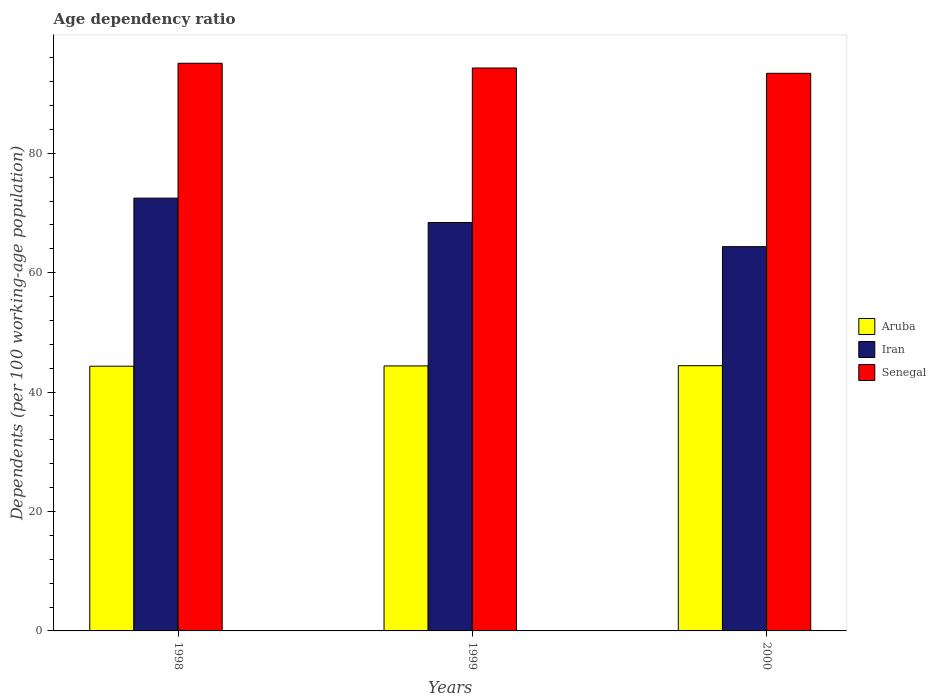How many different coloured bars are there?
Your answer should be compact. 3. How many groups of bars are there?
Your answer should be compact. 3. Are the number of bars on each tick of the X-axis equal?
Keep it short and to the point. Yes. How many bars are there on the 2nd tick from the right?
Your answer should be very brief. 3. What is the age dependency ratio in in Iran in 1999?
Offer a very short reply. 68.4. Across all years, what is the maximum age dependency ratio in in Senegal?
Offer a terse response. 95.07. Across all years, what is the minimum age dependency ratio in in Senegal?
Offer a terse response. 93.39. In which year was the age dependency ratio in in Senegal minimum?
Give a very brief answer. 2000. What is the total age dependency ratio in in Senegal in the graph?
Keep it short and to the point. 282.74. What is the difference between the age dependency ratio in in Iran in 1998 and that in 2000?
Keep it short and to the point. 8.12. What is the difference between the age dependency ratio in in Aruba in 2000 and the age dependency ratio in in Senegal in 1999?
Make the answer very short. -49.85. What is the average age dependency ratio in in Aruba per year?
Keep it short and to the point. 44.38. In the year 2000, what is the difference between the age dependency ratio in in Aruba and age dependency ratio in in Iran?
Ensure brevity in your answer.  -19.94. In how many years, is the age dependency ratio in in Iran greater than 76 %?
Make the answer very short. 0. What is the ratio of the age dependency ratio in in Aruba in 1998 to that in 1999?
Provide a succinct answer. 1. What is the difference between the highest and the second highest age dependency ratio in in Iran?
Ensure brevity in your answer.  4.08. What is the difference between the highest and the lowest age dependency ratio in in Senegal?
Your response must be concise. 1.68. In how many years, is the age dependency ratio in in Senegal greater than the average age dependency ratio in in Senegal taken over all years?
Your answer should be very brief. 2. What does the 2nd bar from the left in 1998 represents?
Your answer should be very brief. Iran. What does the 3rd bar from the right in 1999 represents?
Make the answer very short. Aruba. Is it the case that in every year, the sum of the age dependency ratio in in Senegal and age dependency ratio in in Iran is greater than the age dependency ratio in in Aruba?
Make the answer very short. Yes. How many bars are there?
Give a very brief answer. 9. What is the difference between two consecutive major ticks on the Y-axis?
Ensure brevity in your answer.  20. Does the graph contain grids?
Make the answer very short. No. Where does the legend appear in the graph?
Your response must be concise. Center right. How are the legend labels stacked?
Your answer should be very brief. Vertical. What is the title of the graph?
Ensure brevity in your answer.  Age dependency ratio. Does "St. Lucia" appear as one of the legend labels in the graph?
Ensure brevity in your answer.  No. What is the label or title of the Y-axis?
Provide a succinct answer. Dependents (per 100 working-age population). What is the Dependents (per 100 working-age population) in Aruba in 1998?
Your answer should be very brief. 44.33. What is the Dependents (per 100 working-age population) in Iran in 1998?
Provide a short and direct response. 72.48. What is the Dependents (per 100 working-age population) of Senegal in 1998?
Give a very brief answer. 95.07. What is the Dependents (per 100 working-age population) in Aruba in 1999?
Your response must be concise. 44.38. What is the Dependents (per 100 working-age population) of Iran in 1999?
Provide a succinct answer. 68.4. What is the Dependents (per 100 working-age population) in Senegal in 1999?
Your answer should be compact. 94.28. What is the Dependents (per 100 working-age population) in Aruba in 2000?
Make the answer very short. 44.42. What is the Dependents (per 100 working-age population) of Iran in 2000?
Keep it short and to the point. 64.36. What is the Dependents (per 100 working-age population) in Senegal in 2000?
Ensure brevity in your answer.  93.39. Across all years, what is the maximum Dependents (per 100 working-age population) of Aruba?
Offer a very short reply. 44.42. Across all years, what is the maximum Dependents (per 100 working-age population) of Iran?
Your response must be concise. 72.48. Across all years, what is the maximum Dependents (per 100 working-age population) of Senegal?
Make the answer very short. 95.07. Across all years, what is the minimum Dependents (per 100 working-age population) in Aruba?
Your answer should be compact. 44.33. Across all years, what is the minimum Dependents (per 100 working-age population) in Iran?
Provide a short and direct response. 64.36. Across all years, what is the minimum Dependents (per 100 working-age population) of Senegal?
Your answer should be very brief. 93.39. What is the total Dependents (per 100 working-age population) of Aruba in the graph?
Offer a terse response. 133.13. What is the total Dependents (per 100 working-age population) in Iran in the graph?
Provide a short and direct response. 205.24. What is the total Dependents (per 100 working-age population) of Senegal in the graph?
Keep it short and to the point. 282.74. What is the difference between the Dependents (per 100 working-age population) in Aruba in 1998 and that in 1999?
Keep it short and to the point. -0.04. What is the difference between the Dependents (per 100 working-age population) of Iran in 1998 and that in 1999?
Your answer should be very brief. 4.08. What is the difference between the Dependents (per 100 working-age population) of Senegal in 1998 and that in 1999?
Give a very brief answer. 0.8. What is the difference between the Dependents (per 100 working-age population) of Aruba in 1998 and that in 2000?
Your answer should be compact. -0.09. What is the difference between the Dependents (per 100 working-age population) of Iran in 1998 and that in 2000?
Keep it short and to the point. 8.12. What is the difference between the Dependents (per 100 working-age population) in Senegal in 1998 and that in 2000?
Your answer should be very brief. 1.68. What is the difference between the Dependents (per 100 working-age population) in Aruba in 1999 and that in 2000?
Keep it short and to the point. -0.04. What is the difference between the Dependents (per 100 working-age population) in Iran in 1999 and that in 2000?
Your answer should be compact. 4.04. What is the difference between the Dependents (per 100 working-age population) of Senegal in 1999 and that in 2000?
Provide a short and direct response. 0.89. What is the difference between the Dependents (per 100 working-age population) in Aruba in 1998 and the Dependents (per 100 working-age population) in Iran in 1999?
Offer a terse response. -24.07. What is the difference between the Dependents (per 100 working-age population) of Aruba in 1998 and the Dependents (per 100 working-age population) of Senegal in 1999?
Keep it short and to the point. -49.94. What is the difference between the Dependents (per 100 working-age population) of Iran in 1998 and the Dependents (per 100 working-age population) of Senegal in 1999?
Keep it short and to the point. -21.79. What is the difference between the Dependents (per 100 working-age population) in Aruba in 1998 and the Dependents (per 100 working-age population) in Iran in 2000?
Offer a very short reply. -20.02. What is the difference between the Dependents (per 100 working-age population) of Aruba in 1998 and the Dependents (per 100 working-age population) of Senegal in 2000?
Offer a terse response. -49.05. What is the difference between the Dependents (per 100 working-age population) in Iran in 1998 and the Dependents (per 100 working-age population) in Senegal in 2000?
Provide a short and direct response. -20.91. What is the difference between the Dependents (per 100 working-age population) in Aruba in 1999 and the Dependents (per 100 working-age population) in Iran in 2000?
Ensure brevity in your answer.  -19.98. What is the difference between the Dependents (per 100 working-age population) of Aruba in 1999 and the Dependents (per 100 working-age population) of Senegal in 2000?
Offer a very short reply. -49.01. What is the difference between the Dependents (per 100 working-age population) in Iran in 1999 and the Dependents (per 100 working-age population) in Senegal in 2000?
Your answer should be very brief. -24.99. What is the average Dependents (per 100 working-age population) in Aruba per year?
Your answer should be very brief. 44.38. What is the average Dependents (per 100 working-age population) of Iran per year?
Make the answer very short. 68.41. What is the average Dependents (per 100 working-age population) of Senegal per year?
Offer a very short reply. 94.25. In the year 1998, what is the difference between the Dependents (per 100 working-age population) in Aruba and Dependents (per 100 working-age population) in Iran?
Provide a succinct answer. -28.15. In the year 1998, what is the difference between the Dependents (per 100 working-age population) of Aruba and Dependents (per 100 working-age population) of Senegal?
Keep it short and to the point. -50.74. In the year 1998, what is the difference between the Dependents (per 100 working-age population) of Iran and Dependents (per 100 working-age population) of Senegal?
Make the answer very short. -22.59. In the year 1999, what is the difference between the Dependents (per 100 working-age population) of Aruba and Dependents (per 100 working-age population) of Iran?
Give a very brief answer. -24.02. In the year 1999, what is the difference between the Dependents (per 100 working-age population) in Aruba and Dependents (per 100 working-age population) in Senegal?
Keep it short and to the point. -49.9. In the year 1999, what is the difference between the Dependents (per 100 working-age population) of Iran and Dependents (per 100 working-age population) of Senegal?
Provide a short and direct response. -25.87. In the year 2000, what is the difference between the Dependents (per 100 working-age population) of Aruba and Dependents (per 100 working-age population) of Iran?
Make the answer very short. -19.94. In the year 2000, what is the difference between the Dependents (per 100 working-age population) of Aruba and Dependents (per 100 working-age population) of Senegal?
Keep it short and to the point. -48.97. In the year 2000, what is the difference between the Dependents (per 100 working-age population) of Iran and Dependents (per 100 working-age population) of Senegal?
Your answer should be compact. -29.03. What is the ratio of the Dependents (per 100 working-age population) of Iran in 1998 to that in 1999?
Your response must be concise. 1.06. What is the ratio of the Dependents (per 100 working-age population) in Senegal in 1998 to that in 1999?
Offer a very short reply. 1.01. What is the ratio of the Dependents (per 100 working-age population) of Iran in 1998 to that in 2000?
Offer a terse response. 1.13. What is the ratio of the Dependents (per 100 working-age population) in Senegal in 1998 to that in 2000?
Offer a very short reply. 1.02. What is the ratio of the Dependents (per 100 working-age population) of Iran in 1999 to that in 2000?
Offer a terse response. 1.06. What is the ratio of the Dependents (per 100 working-age population) of Senegal in 1999 to that in 2000?
Ensure brevity in your answer.  1.01. What is the difference between the highest and the second highest Dependents (per 100 working-age population) in Aruba?
Offer a very short reply. 0.04. What is the difference between the highest and the second highest Dependents (per 100 working-age population) in Iran?
Keep it short and to the point. 4.08. What is the difference between the highest and the second highest Dependents (per 100 working-age population) in Senegal?
Keep it short and to the point. 0.8. What is the difference between the highest and the lowest Dependents (per 100 working-age population) in Aruba?
Offer a very short reply. 0.09. What is the difference between the highest and the lowest Dependents (per 100 working-age population) in Iran?
Your response must be concise. 8.12. What is the difference between the highest and the lowest Dependents (per 100 working-age population) of Senegal?
Your answer should be compact. 1.68. 